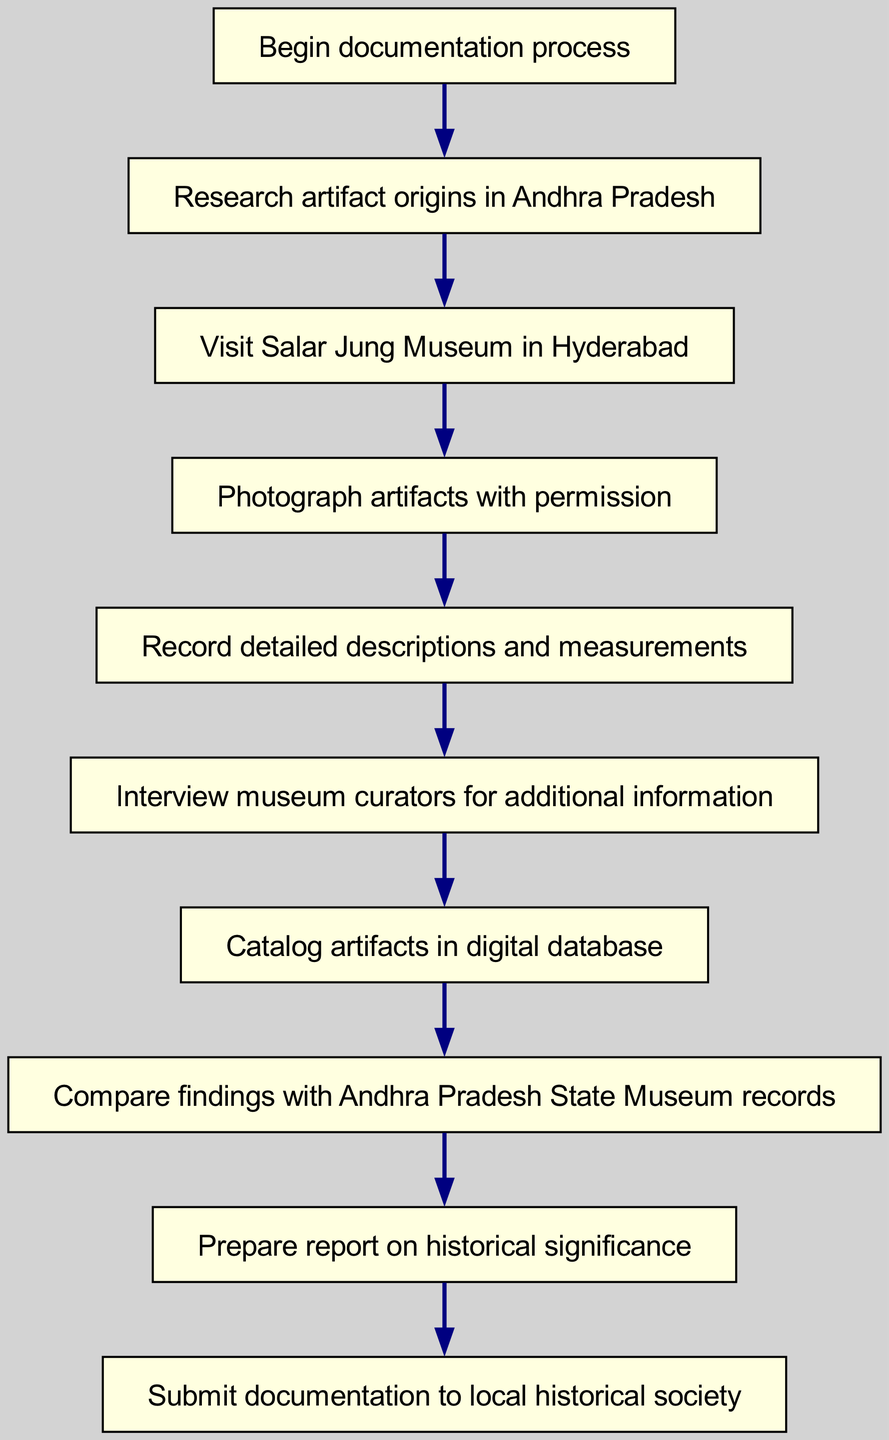What is the starting point of the documentation process? The diagram indicates that the starting point is labeled as "Begin documentation process". This is the first node in the flowchart.
Answer: Begin documentation process How many nodes are present in the diagram? By counting the nodes listed in the data, there are a total of 10 nodes. Each node represents a step in the documentation process.
Answer: 10 What follows the step "Photograph artifacts with permission"? According to the flowchart, the step that follows "Photograph artifacts with permission" is "Record detailed descriptions and measurements". This indicates the progression of tasks after photographing the artifacts.
Answer: Record detailed descriptions and measurements What is the terminal point of this process? The terminal point of the documentation process, as shown in the diagram, is "Submit documentation to local historical society". This is the last step in the flowchart.
Answer: Submit documentation to local historical society What two steps are directly connected before cataloging artifacts? The steps that are directly connected before cataloging artifacts are "Interview museum curators for additional information" and "Catalog artifacts in digital database". These steps demonstrate a logical sequence leading into the cataloging process.
Answer: Interview museum curators for additional information, Catalog artifacts in digital database If the research is not completed, which step should be revisited based on the flowchart? If the research is not completed, the flowchart indicates that the process should revert back to the "Research artifact origins in Andhra Pradesh" node. This indicates that proper research is vital before proceeding to the next step.
Answer: Research artifact origins in Andhra Pradesh How many total edges are there in the flowchart? The number of edges can be calculated by counting the connections between nodes. Based on the data provided, there are 9 edges connecting the various steps in the process.
Answer: 9 Which node represents the action of gathering visual documentation? The node representing the action of gathering visual documentation is "Photograph artifacts with permission". This defines a specific action within the overall documentation process.
Answer: Photograph artifacts with permission What may be required to enhance the documentation process, according to the flowchart? To enhance the documentation process, according to the flowchart, one may need to "Interview museum curators for additional information". This step suggests that gaining insights from curators can enrich the overall information being documented.
Answer: Interview museum curators for additional information 